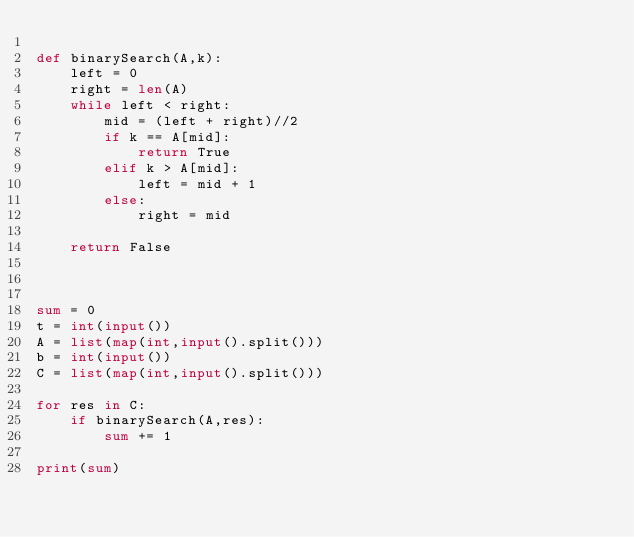Convert code to text. <code><loc_0><loc_0><loc_500><loc_500><_Python_>
def binarySearch(A,k):
    left = 0
    right = len(A)
    while left < right:
        mid = (left + right)//2
        if k == A[mid]:
            return True
        elif k > A[mid]:
            left = mid + 1
        else:
            right = mid

    return False



sum = 0
t = int(input())
A = list(map(int,input().split()))
b = int(input())
C = list(map(int,input().split()))

for res in C:
    if binarySearch(A,res):
        sum += 1

print(sum)

</code> 